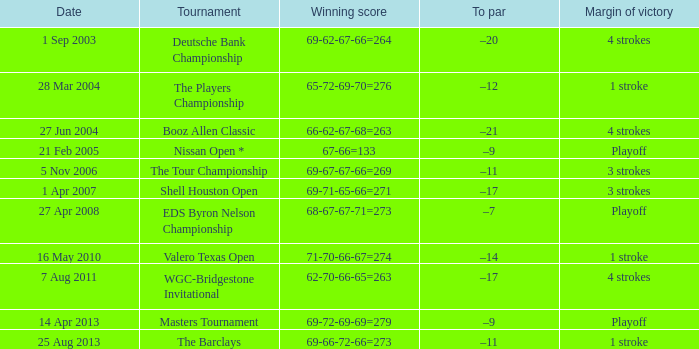Which date features a to par of -12? 28 Mar 2004. 